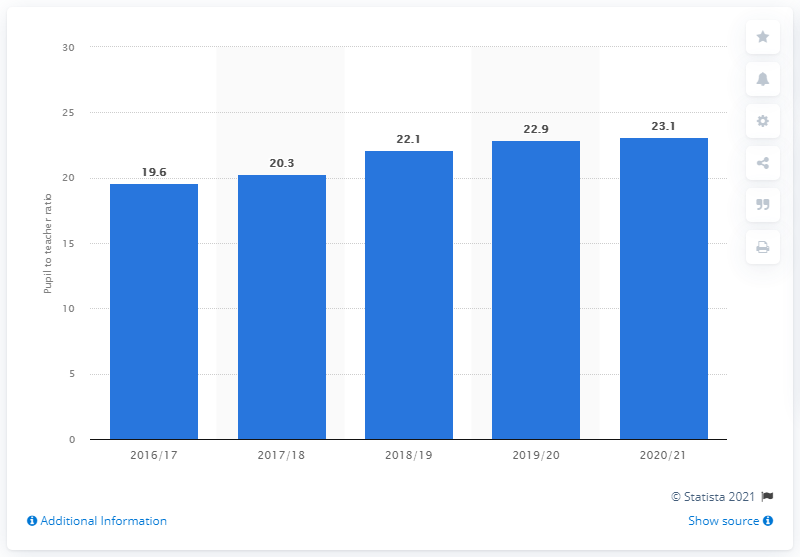List a handful of essential elements in this visual. In the 2020/21 school year, the pupil-to-teacher ratio in primary education in Vietnam was 23.1. 